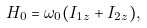<formula> <loc_0><loc_0><loc_500><loc_500>H _ { 0 } = \omega _ { 0 } ( I _ { 1 z } + I _ { 2 z } ) ,</formula> 